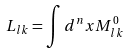Convert formula to latex. <formula><loc_0><loc_0><loc_500><loc_500>L _ { l k } = \int d ^ { n } x M ^ { 0 } _ { l k }</formula> 